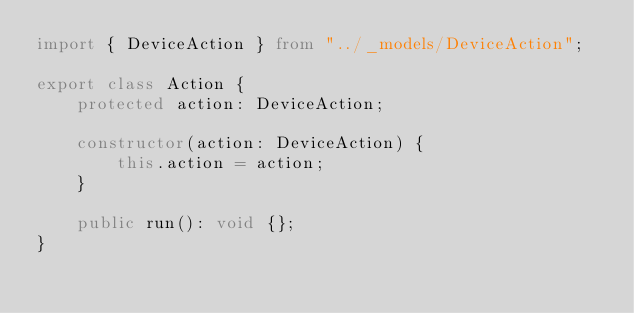Convert code to text. <code><loc_0><loc_0><loc_500><loc_500><_TypeScript_>import { DeviceAction } from "../_models/DeviceAction";

export class Action {
    protected action: DeviceAction;

    constructor(action: DeviceAction) {
        this.action = action;
    }

    public run(): void {};
}</code> 